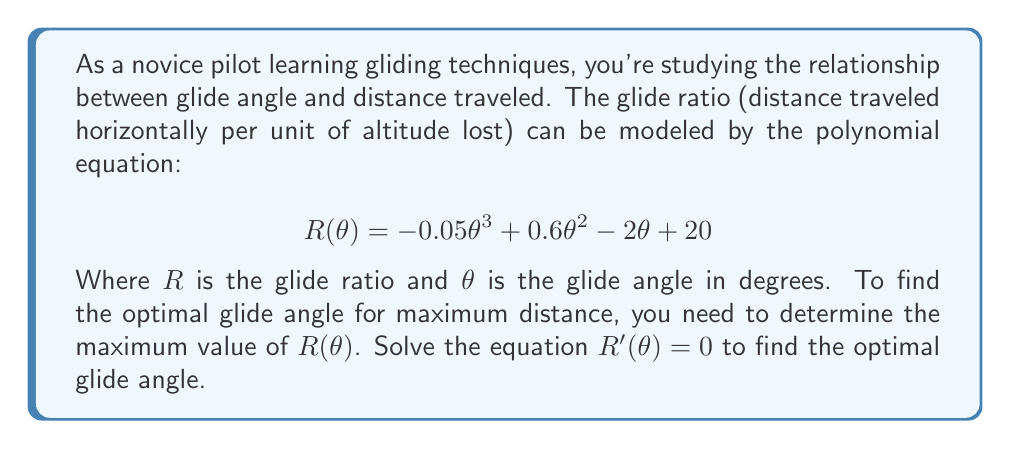Solve this math problem. To find the optimal glide angle, we need to follow these steps:

1) First, we need to find the derivative of $R(θ)$:
   
   $$R'(θ) = -0.15θ^2 + 1.2θ - 2$$

2) Set $R'(θ) = 0$ to find the critical points:
   
   $$-0.15θ^2 + 1.2θ - 2 = 0$$

3) This is a quadratic equation. We can solve it using the quadratic formula:
   
   $$θ = \frac{-b \pm \sqrt{b^2 - 4ac}}{2a}$$
   
   Where $a = -0.15$, $b = 1.2$, and $c = -2$

4) Substituting these values:

   $$θ = \frac{-1.2 \pm \sqrt{1.2^2 - 4(-0.15)(-2)}}{2(-0.15)}$$
   
   $$= \frac{-1.2 \pm \sqrt{1.44 - 1.2}}{-0.3}$$
   
   $$= \frac{-1.2 \pm \sqrt{0.24}}{-0.3}$$
   
   $$= \frac{-1.2 \pm 0.4899}{-0.3}$$

5) This gives us two solutions:

   $$θ_1 = \frac{-1.2 + 0.4899}{-0.3} \approx 2.37$$
   
   $$θ_2 = \frac{-1.2 - 0.4899}{-0.3} \approx 5.63$$

6) To determine which of these gives the maximum glide ratio, we can check the second derivative at these points or simply evaluate $R(θ)$ at both points.

   The second derivative is:
   $$R''(θ) = -0.3θ + 1.2$$

   At $θ_1 = 2.37$: $R''(2.37) = 0.489 > 0$, indicating a local minimum.
   At $θ_2 = 5.63$: $R''(5.63) = -0.489 < 0$, indicating a local maximum.

Therefore, the optimal glide angle for maximum distance is approximately 5.63 degrees.
Answer: The optimal glide angle for maximum distance is approximately 5.63 degrees. 